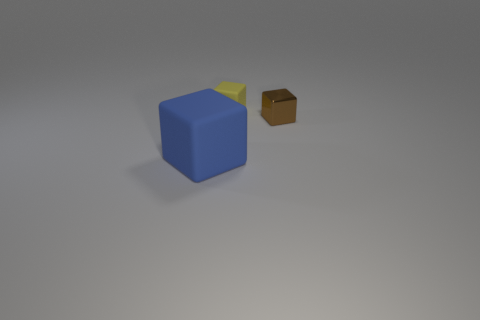Add 1 large shiny balls. How many objects exist? 4 Subtract 1 blue cubes. How many objects are left? 2 Subtract all small brown metallic things. Subtract all large blocks. How many objects are left? 1 Add 3 tiny brown shiny cubes. How many tiny brown shiny cubes are left? 4 Add 2 purple cylinders. How many purple cylinders exist? 2 